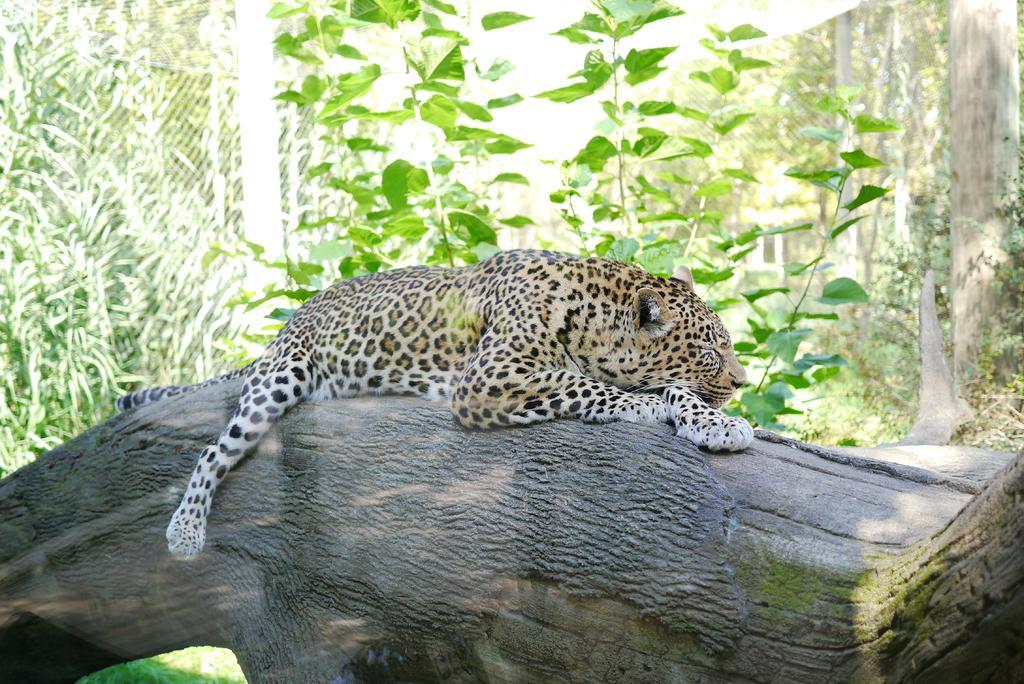How would you summarize this image in a sentence or two? In this image there is a tree trunk on which there is a tiger. In the background there are tall trees. 